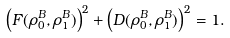Convert formula to latex. <formula><loc_0><loc_0><loc_500><loc_500>\left ( F ( \rho _ { 0 } ^ { B } , \rho _ { 1 } ^ { B } ) \right ) ^ { 2 } + \left ( D ( \rho _ { 0 } ^ { B } , \rho _ { 1 } ^ { B } ) \right ) ^ { 2 } = 1 .</formula> 